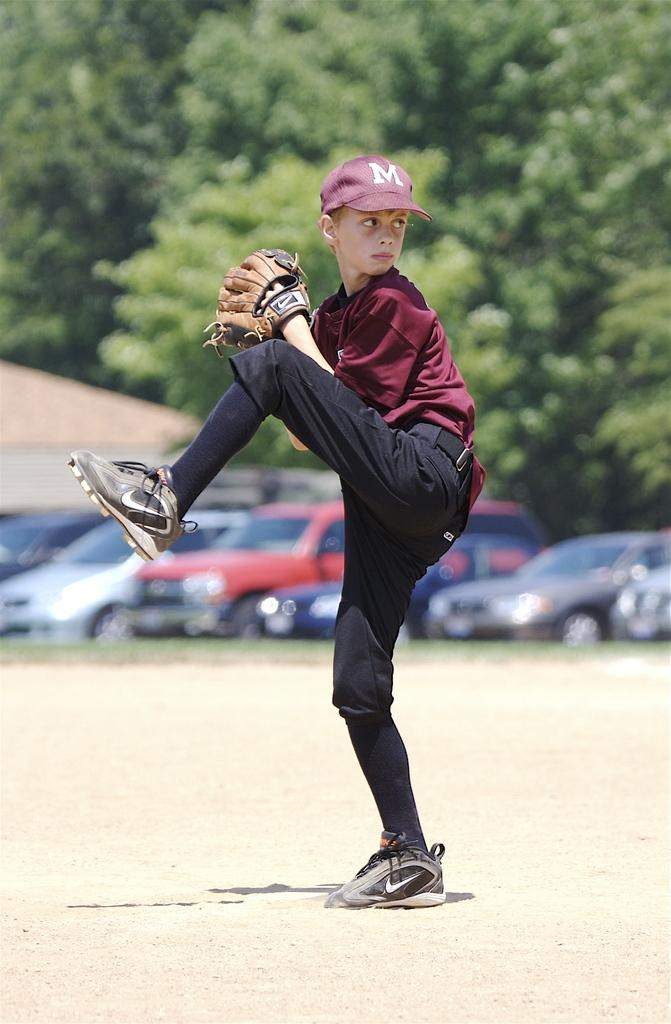Who is in the picture? There is a boy in the picture. What is the boy doing in the picture? The boy is standing on one leg in the picture. What accessories is the boy wearing in the picture? The boy is wearing gloves on his hands and a cap on his head in the picture. What can be seen in the background of the image? There are trees visible in the background of the image. What else is present in the image besides the boy? There are cars parked in the image. What type of hose is the boy holding in the image? There is no hose present in the image; the boy is wearing gloves on his hands. What type of quiver is the boy using to store his baseball equipment in the image? There is no quiver or baseball equipment present in the image; the boy is wearing gloves and a cap. 